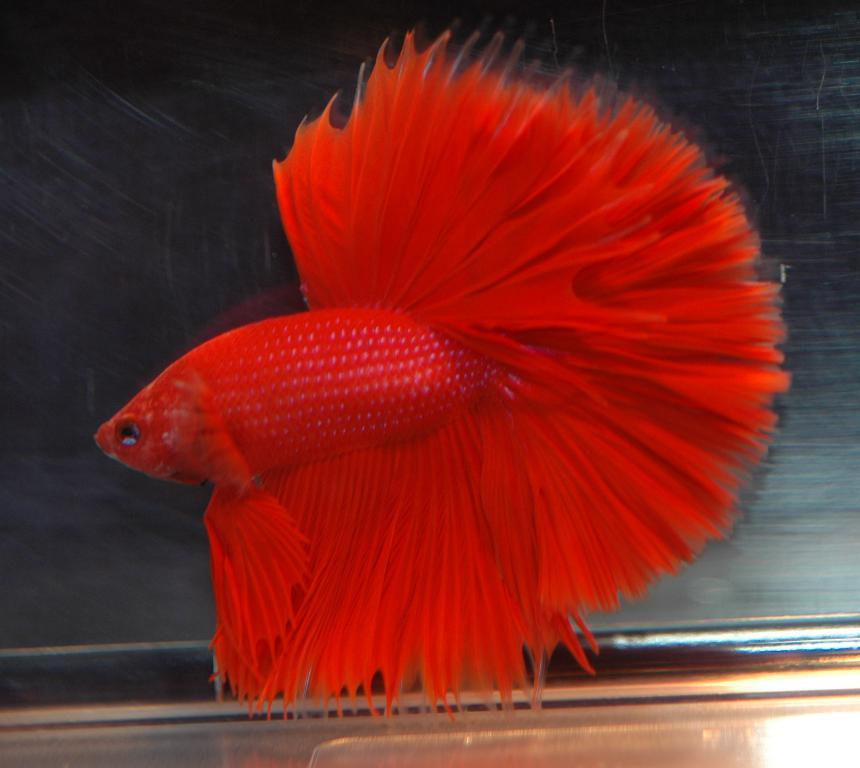What type of animal is in the image? There is a fish in the image. What color is the fish? The fish is red in color. Where is the fish located? The fish is in an aquarium. Can you see the fish kissing the wren in the image? There is no wren present in the image, and the fish is not shown kissing anything. 